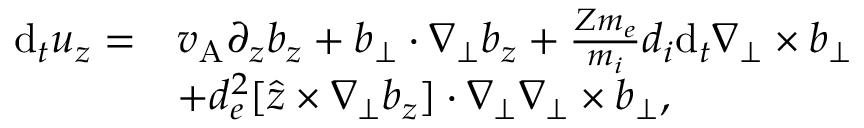Convert formula to latex. <formula><loc_0><loc_0><loc_500><loc_500>\begin{array} { r l } { d _ { t } u _ { z } = } & { v _ { A } \partial _ { z } b _ { z } + b _ { \perp } \cdot \nabla _ { \perp } b _ { z } + \frac { Z m _ { e } } { m _ { i } } d _ { i } d _ { t } \nabla _ { \perp } \times b _ { \perp } } \\ & { + d _ { e } ^ { 2 } [ \hat { z } \times \nabla _ { \perp } b _ { z } ] \cdot \nabla _ { \perp } \nabla _ { \perp } \times b _ { \perp } , } \end{array}</formula> 